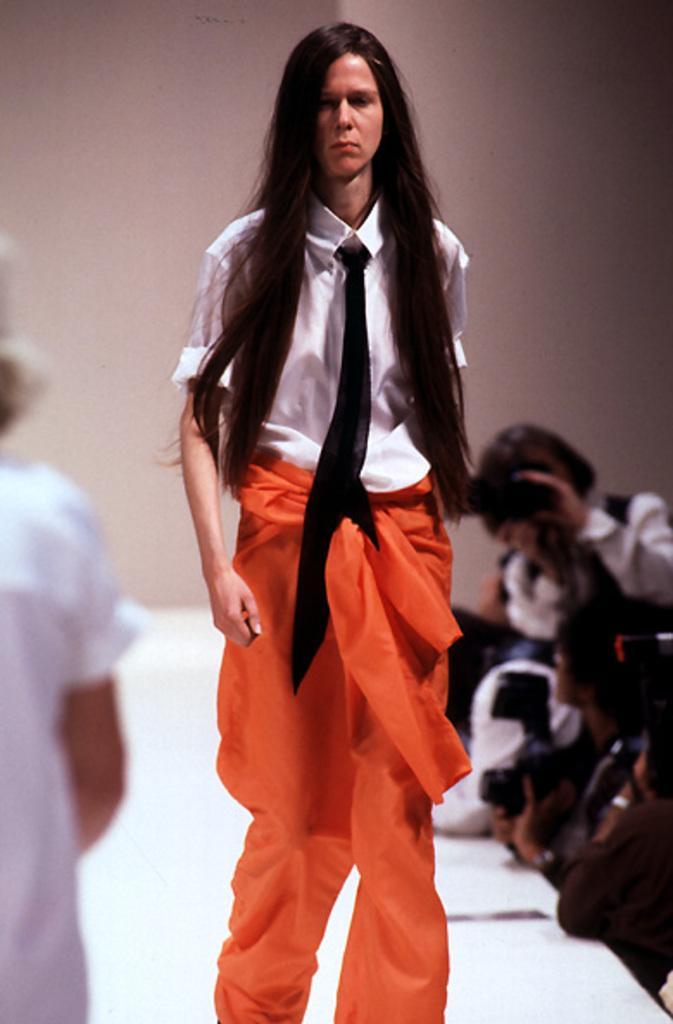Could you give a brief overview of what you see in this image? In this image in the front there is a person walking. In the background there are persons and on the right side there are persons holding cameras in their hand and there is a wall. 